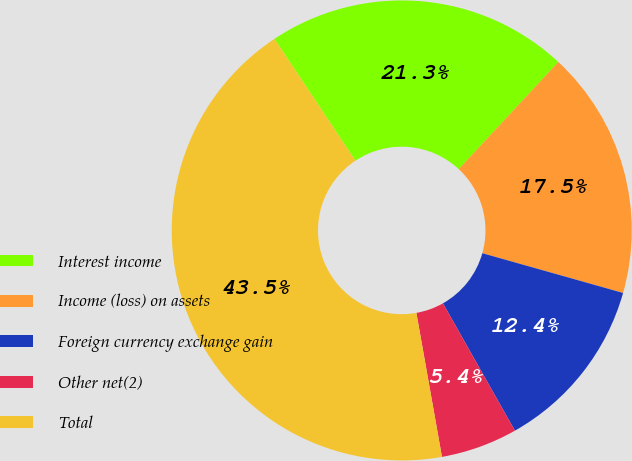Convert chart to OTSL. <chart><loc_0><loc_0><loc_500><loc_500><pie_chart><fcel>Interest income<fcel>Income (loss) on assets<fcel>Foreign currency exchange gain<fcel>Other net(2)<fcel>Total<nl><fcel>21.26%<fcel>17.46%<fcel>12.43%<fcel>5.39%<fcel>43.46%<nl></chart> 